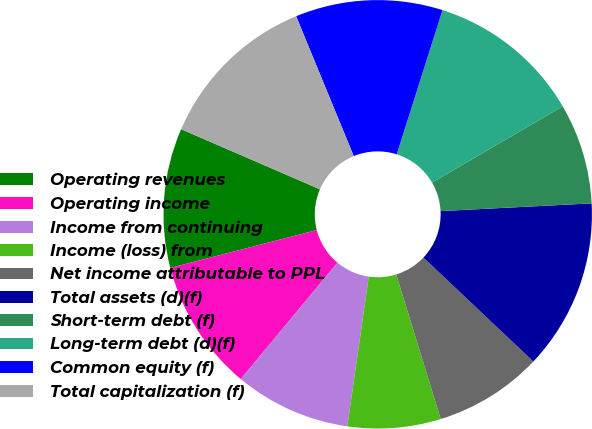Convert chart. <chart><loc_0><loc_0><loc_500><loc_500><pie_chart><fcel>Operating revenues<fcel>Operating income<fcel>Income from continuing<fcel>Income (loss) from<fcel>Net income attributable to PPL<fcel>Total assets (d)(f)<fcel>Short-term debt (f)<fcel>Long-term debt (d)(f)<fcel>Common equity (f)<fcel>Total capitalization (f)<nl><fcel>10.53%<fcel>9.94%<fcel>8.77%<fcel>7.02%<fcel>8.19%<fcel>12.87%<fcel>7.6%<fcel>11.7%<fcel>11.11%<fcel>12.28%<nl></chart> 